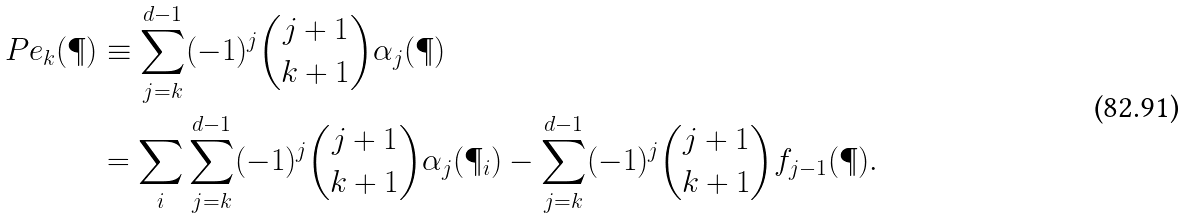Convert formula to latex. <formula><loc_0><loc_0><loc_500><loc_500>P e _ { k } ( \P ) & \equiv \sum _ { j = k } ^ { d - 1 } ( - 1 ) ^ { j } { j + 1 \choose k + 1 } \alpha _ { j } ( \P ) \\ & = \sum _ { i } \sum _ { j = k } ^ { d - 1 } ( - 1 ) ^ { j } { j + 1 \choose k + 1 } \alpha _ { j } ( \P _ { i } ) - \sum _ { j = k } ^ { d - 1 } ( - 1 ) ^ { j } { j + 1 \choose k + 1 } f _ { j - 1 } ( \P ) .</formula> 